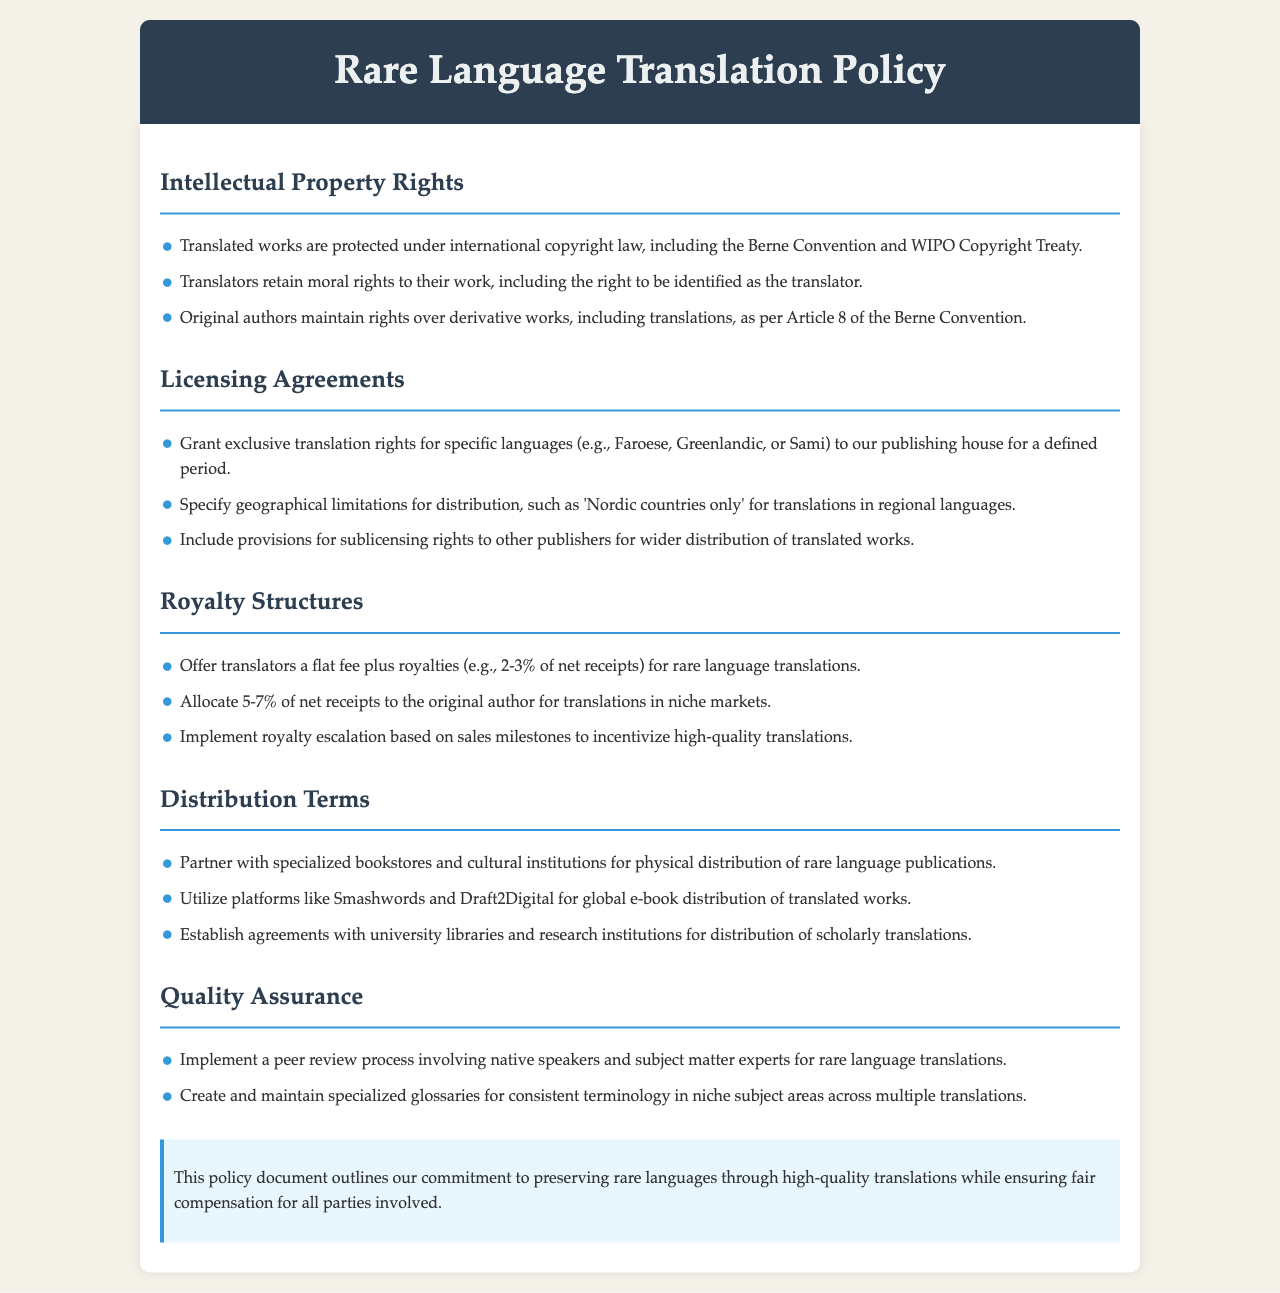What international copyright laws protect translated works? The document mentions that translated works are protected under international copyright law, including the Berne Convention and WIPO Copyright Treaty.
Answer: Berne Convention and WIPO Copyright Treaty What rights do translators retain for their work? According to the document, translators retain moral rights, including the right to be identified as the translator.
Answer: Moral rights What percentage of net receipts is allocated to original authors in niche markets? The document states that 5-7% of net receipts is allocated to the original author for translations in niche markets.
Answer: 5-7% Which digital platforms are mentioned for global e-book distribution? The document lists Smashwords and Draft2Digital as platforms for global e-book distribution of translated works.
Answer: Smashwords and Draft2Digital What process is implemented for quality assurance in rare language translations? The document indicates that a peer review process involving native speakers and subject matter experts is implemented for quality assurance.
Answer: Peer review process What is the defined royalty structure for translators of rare language translations? The document states that translators receive a flat fee plus royalties, specifically 2-3% of net receipts for rare language translations.
Answer: 2-3% Which specific geographical limitations are specified for distribution rights? The document specifies that geographical limitations for distribution may include 'Nordic countries only' for translations in regional languages.
Answer: Nordic countries only What is the purpose of creating specialized glossaries? According to the document, specialized glossaries are created for consistent terminology in niche subject areas across multiple translations.
Answer: Consistent terminology What is the highlight of the policy document’s commitment? The document emphasizes its commitment to preserving rare languages through high-quality translations while ensuring fair compensation.
Answer: Fair compensation 